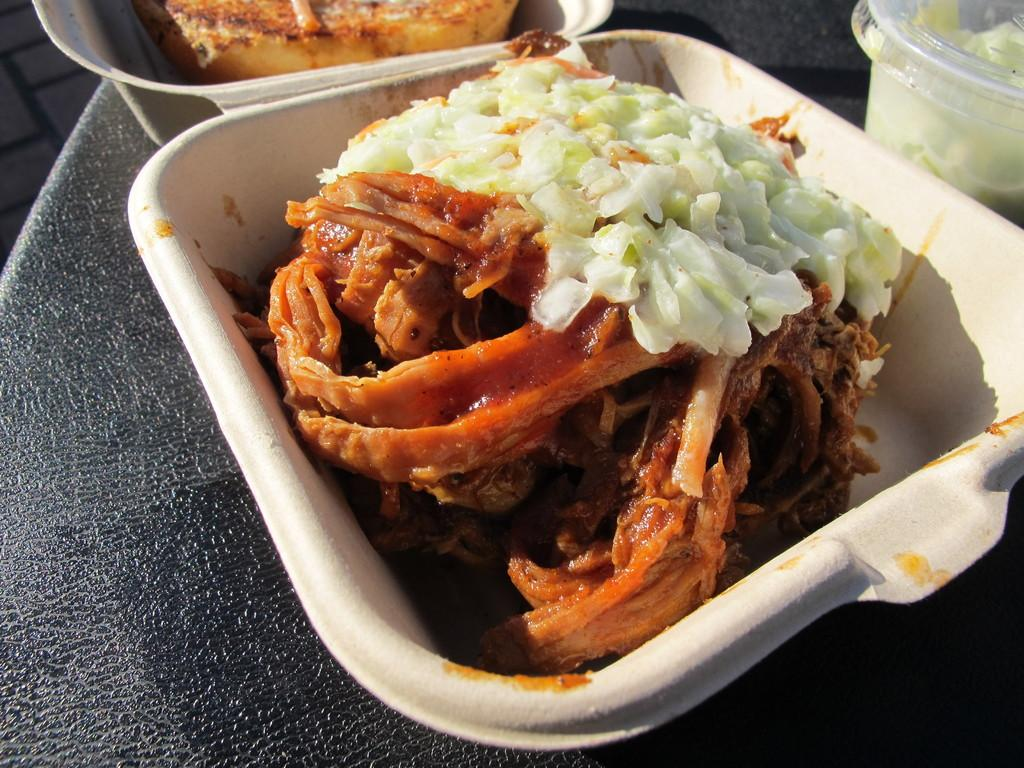What object can be seen in the image that might contain items? There is a box in the image that might contain items. What type of food items are visible in the image? The bowls in the image contain food items. Where are the bowls located in the image? The bowls are placed on a table in the image. Can you describe the setting of the image? The image is likely taken in a room, as there is a table present. How many cars can be seen in the image? There are no cars present in the image. What type of ray is visible in the image? There is no ray visible in the image. 